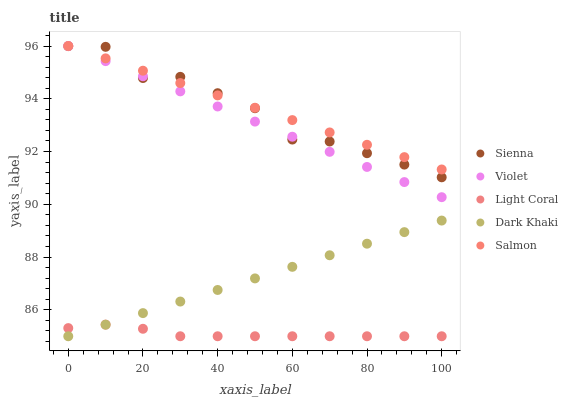Does Light Coral have the minimum area under the curve?
Answer yes or no. Yes. Does Salmon have the maximum area under the curve?
Answer yes or no. Yes. Does Salmon have the minimum area under the curve?
Answer yes or no. No. Does Light Coral have the maximum area under the curve?
Answer yes or no. No. Is Salmon the smoothest?
Answer yes or no. Yes. Is Sienna the roughest?
Answer yes or no. Yes. Is Light Coral the smoothest?
Answer yes or no. No. Is Light Coral the roughest?
Answer yes or no. No. Does Light Coral have the lowest value?
Answer yes or no. Yes. Does Salmon have the lowest value?
Answer yes or no. No. Does Violet have the highest value?
Answer yes or no. Yes. Does Light Coral have the highest value?
Answer yes or no. No. Is Light Coral less than Sienna?
Answer yes or no. Yes. Is Salmon greater than Dark Khaki?
Answer yes or no. Yes. Does Violet intersect Sienna?
Answer yes or no. Yes. Is Violet less than Sienna?
Answer yes or no. No. Is Violet greater than Sienna?
Answer yes or no. No. Does Light Coral intersect Sienna?
Answer yes or no. No. 